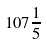<formula> <loc_0><loc_0><loc_500><loc_500>1 0 7 \frac { 1 } { 5 }</formula> 